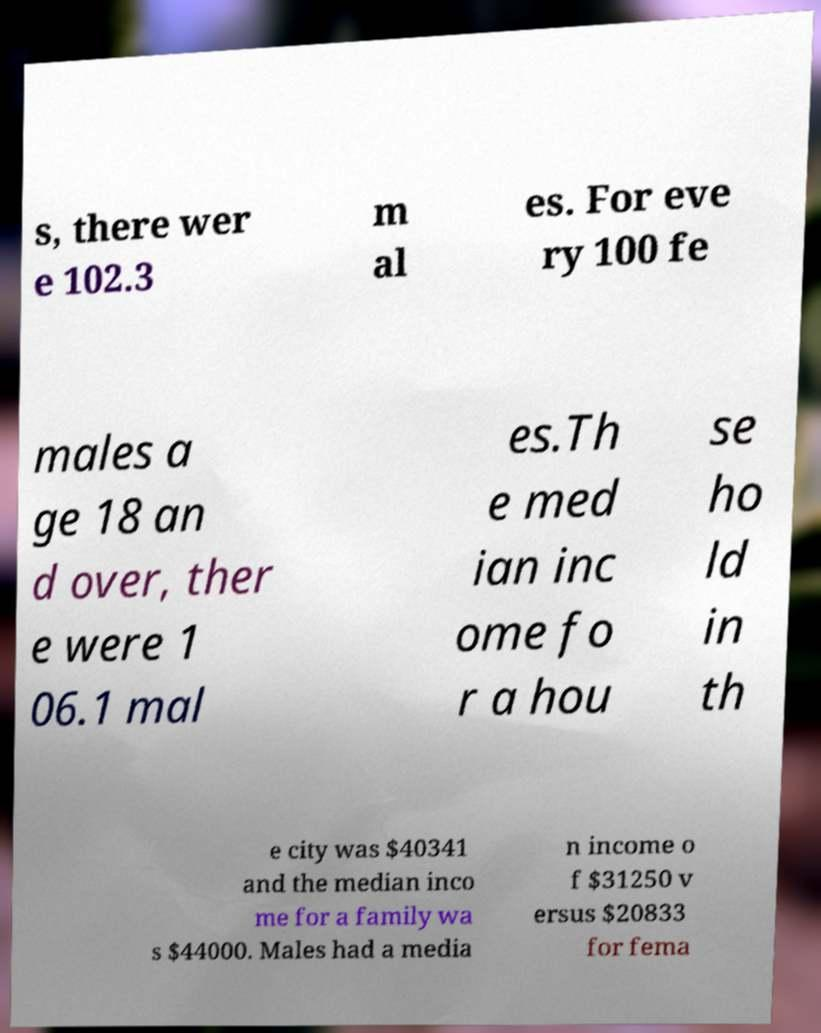Could you assist in decoding the text presented in this image and type it out clearly? s, there wer e 102.3 m al es. For eve ry 100 fe males a ge 18 an d over, ther e were 1 06.1 mal es.Th e med ian inc ome fo r a hou se ho ld in th e city was $40341 and the median inco me for a family wa s $44000. Males had a media n income o f $31250 v ersus $20833 for fema 